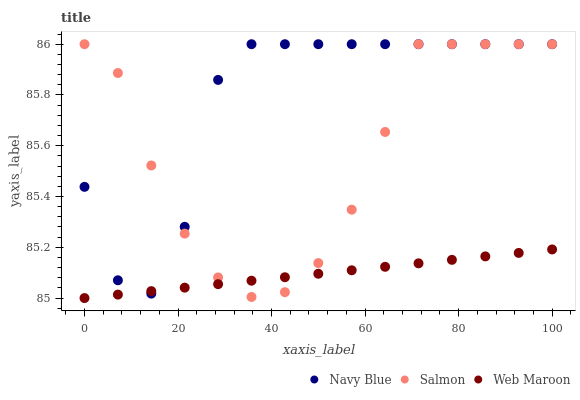Does Web Maroon have the minimum area under the curve?
Answer yes or no. Yes. Does Navy Blue have the maximum area under the curve?
Answer yes or no. Yes. Does Salmon have the minimum area under the curve?
Answer yes or no. No. Does Salmon have the maximum area under the curve?
Answer yes or no. No. Is Web Maroon the smoothest?
Answer yes or no. Yes. Is Navy Blue the roughest?
Answer yes or no. Yes. Is Salmon the smoothest?
Answer yes or no. No. Is Salmon the roughest?
Answer yes or no. No. Does Web Maroon have the lowest value?
Answer yes or no. Yes. Does Salmon have the lowest value?
Answer yes or no. No. Does Salmon have the highest value?
Answer yes or no. Yes. Does Web Maroon have the highest value?
Answer yes or no. No. Does Web Maroon intersect Salmon?
Answer yes or no. Yes. Is Web Maroon less than Salmon?
Answer yes or no. No. Is Web Maroon greater than Salmon?
Answer yes or no. No. 